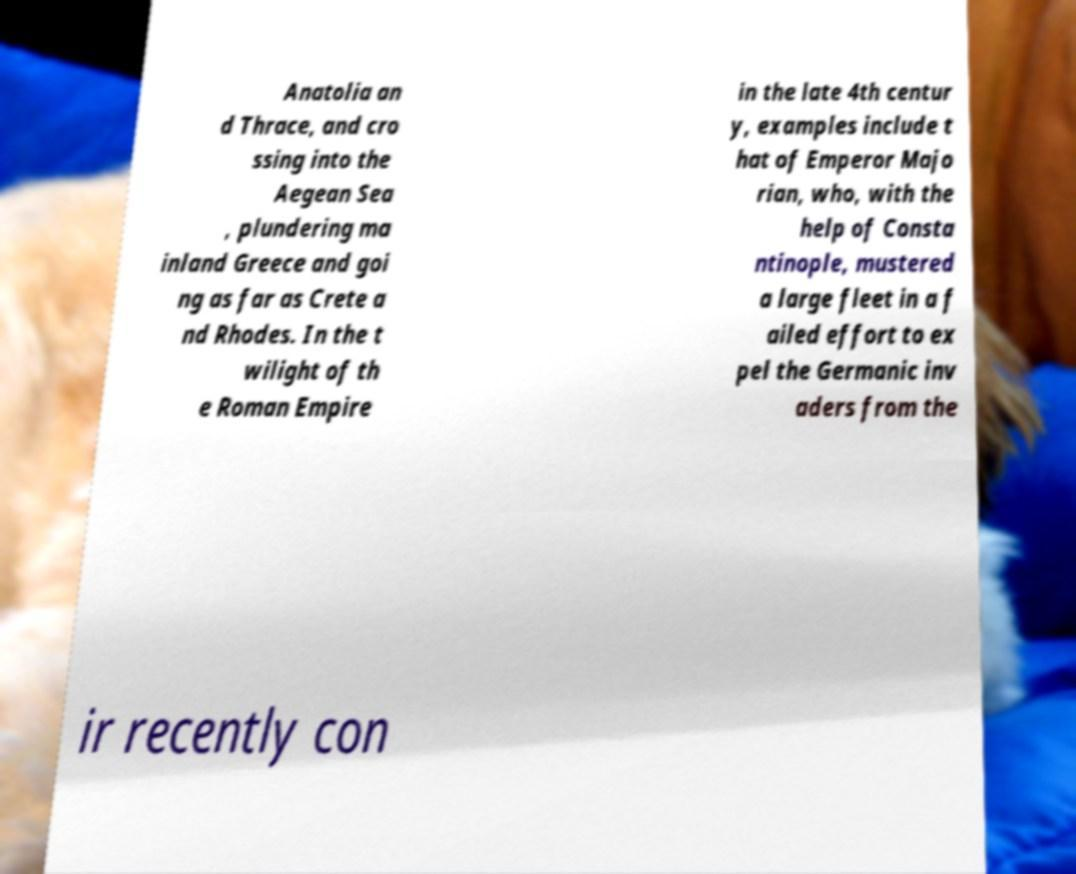What messages or text are displayed in this image? I need them in a readable, typed format. Anatolia an d Thrace, and cro ssing into the Aegean Sea , plundering ma inland Greece and goi ng as far as Crete a nd Rhodes. In the t wilight of th e Roman Empire in the late 4th centur y, examples include t hat of Emperor Majo rian, who, with the help of Consta ntinople, mustered a large fleet in a f ailed effort to ex pel the Germanic inv aders from the ir recently con 